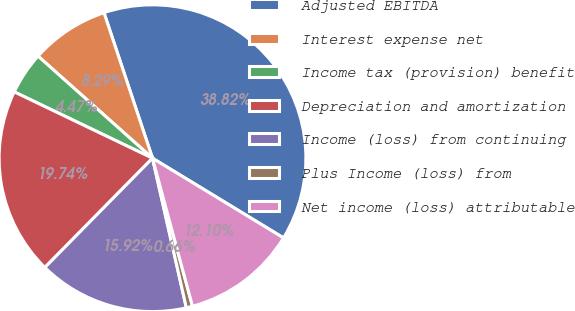Convert chart to OTSL. <chart><loc_0><loc_0><loc_500><loc_500><pie_chart><fcel>Adjusted EBITDA<fcel>Interest expense net<fcel>Income tax (provision) benefit<fcel>Depreciation and amortization<fcel>Income (loss) from continuing<fcel>Plus Income (loss) from<fcel>Net income (loss) attributable<nl><fcel>38.82%<fcel>8.29%<fcel>4.47%<fcel>19.74%<fcel>15.92%<fcel>0.66%<fcel>12.1%<nl></chart> 